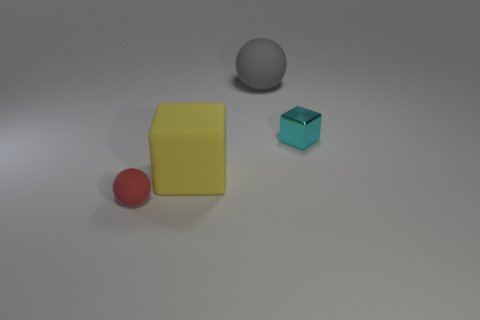Add 1 large blocks. How many objects exist? 5 Add 1 yellow objects. How many yellow objects are left? 2 Add 1 gray objects. How many gray objects exist? 2 Subtract 0 green cylinders. How many objects are left? 4 Subtract all cyan things. Subtract all rubber balls. How many objects are left? 1 